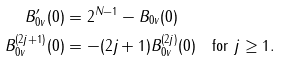<formula> <loc_0><loc_0><loc_500><loc_500>B ^ { \prime } _ { 0 v } ( 0 ) & = 2 ^ { N - 1 } - B _ { 0 v } ( 0 ) \\ B _ { 0 v } ^ { ( 2 j + 1 ) } ( 0 ) & = - ( 2 j + 1 ) B _ { 0 v } ^ { ( 2 j ) } ( 0 ) \quad \text {for $j \geq 1$} .</formula> 